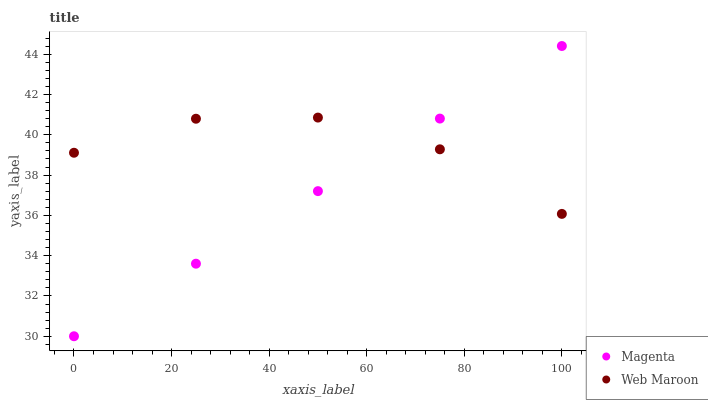Does Magenta have the minimum area under the curve?
Answer yes or no. Yes. Does Web Maroon have the maximum area under the curve?
Answer yes or no. Yes. Does Web Maroon have the minimum area under the curve?
Answer yes or no. No. Is Magenta the smoothest?
Answer yes or no. Yes. Is Web Maroon the roughest?
Answer yes or no. Yes. Is Web Maroon the smoothest?
Answer yes or no. No. Does Magenta have the lowest value?
Answer yes or no. Yes. Does Web Maroon have the lowest value?
Answer yes or no. No. Does Magenta have the highest value?
Answer yes or no. Yes. Does Web Maroon have the highest value?
Answer yes or no. No. Does Magenta intersect Web Maroon?
Answer yes or no. Yes. Is Magenta less than Web Maroon?
Answer yes or no. No. Is Magenta greater than Web Maroon?
Answer yes or no. No. 